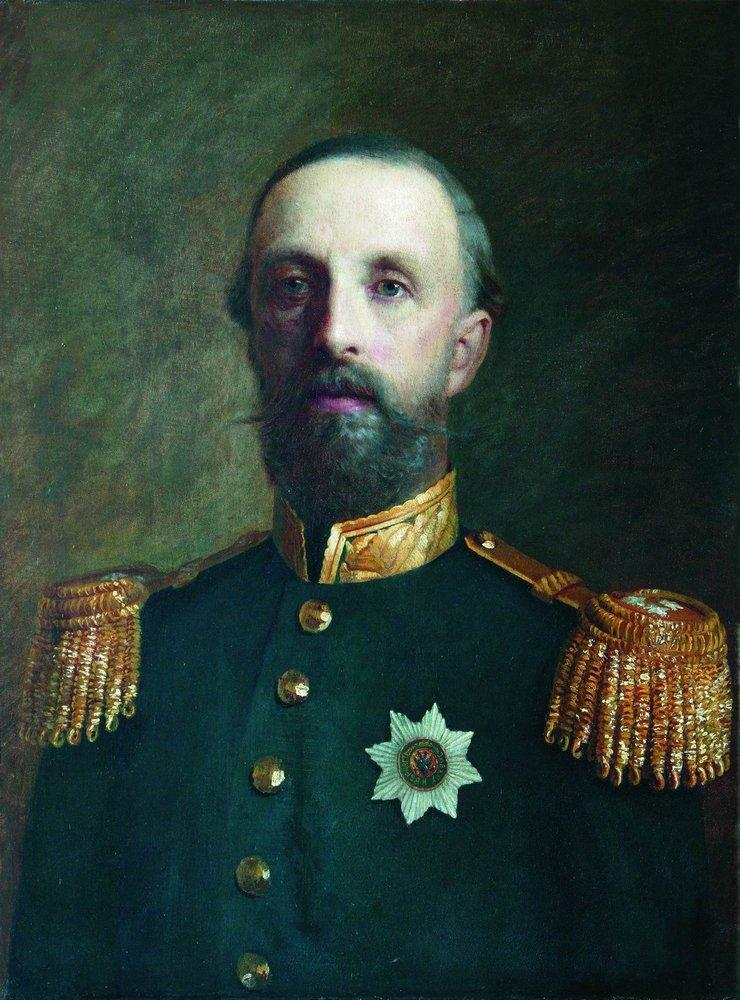What is this photo about? The image is a portrait of a distinguished military figure, possibly from the late 19th or early 20th century. His attire, characterized by a dark blue jacket and richly adorned with gold epaulettes and a striking white star medal, signifies his high rank and honors earned. His poised demeanor and the subtle, yet direct gaze suggest a person of authority and experience. The portrait, executed in a realist style, emphasizes the detailed rendering of his facial features and uniform, highlighting the meticulous care in his presentation and the importance of his role. 